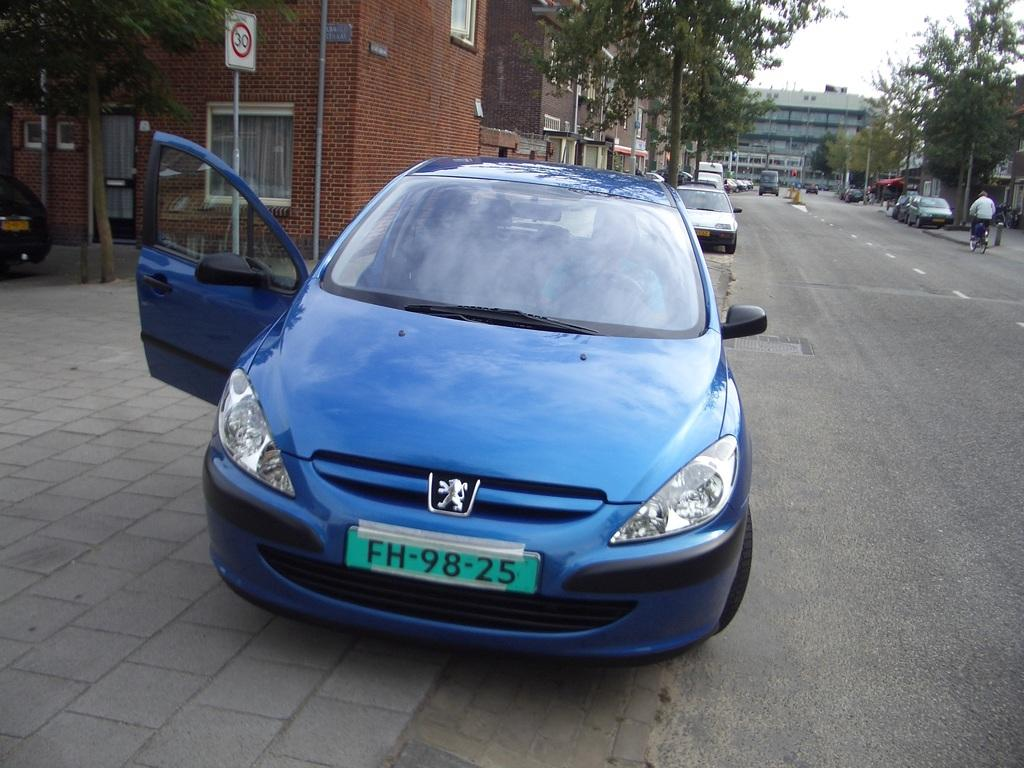<image>
Create a compact narrative representing the image presented. the number 98 is on the license plate of a car 